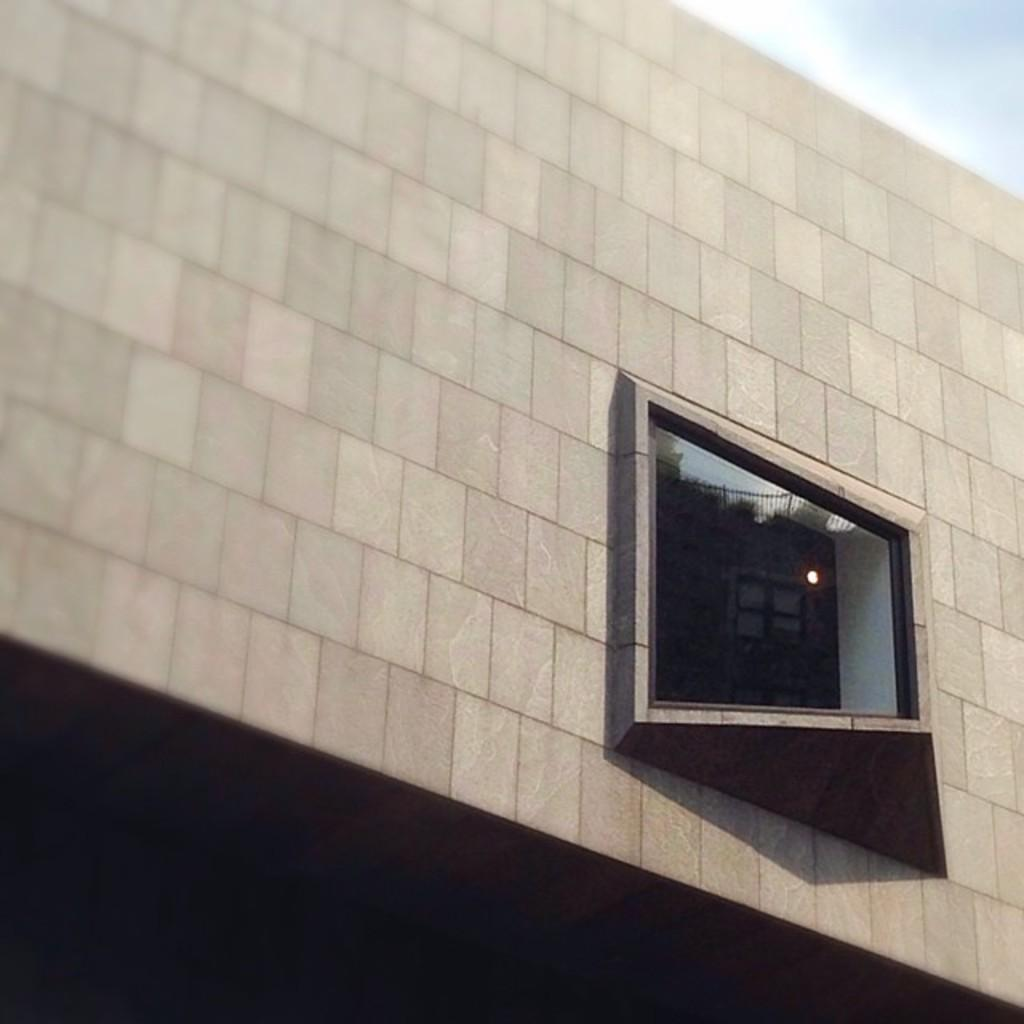What is located in the middle of the picture? There is a wall in the middle of the picture. Where is the window positioned in the picture? The window is on the right side of the picture. What can be seen in the background of the picture? The sky is visible in the background of the picture. What type of food is being served to the slaves in the image? There are no slaves or food present in the image; it only features a wall and a window. How does the hearing aid help the person in the image? There is no person or hearing aid present in the image; it only features a wall and a window. 